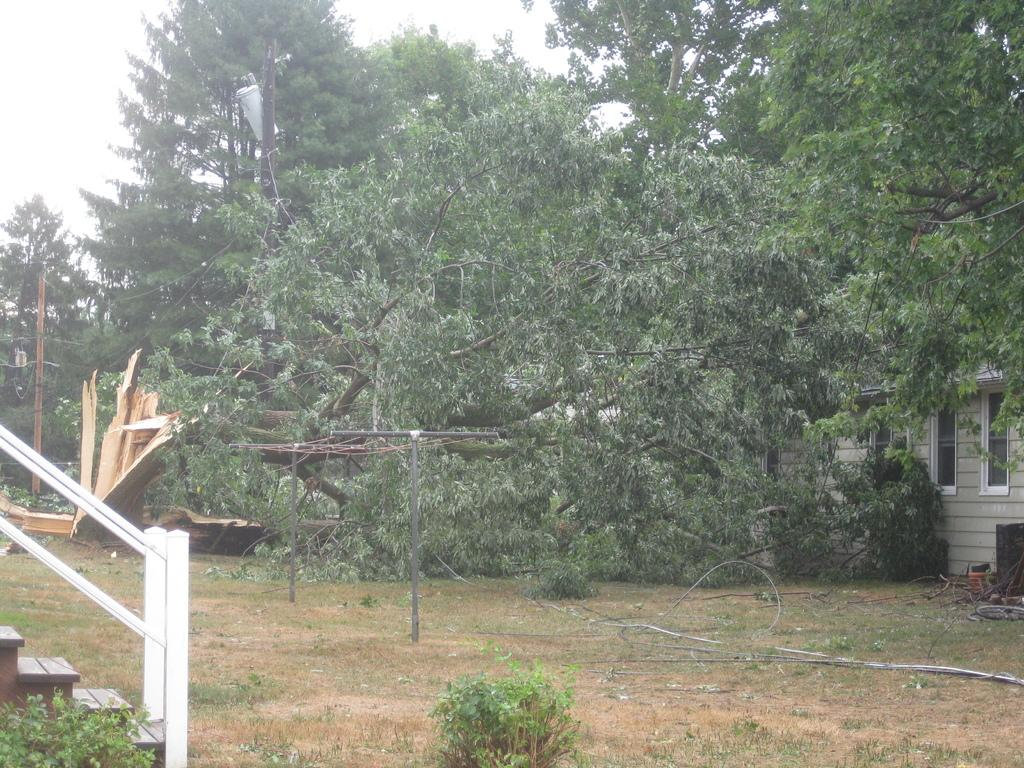What type of terrain is visible in the image? There is a land visible in the image. What architectural feature can be seen in the image? There are stairs in the image. What type of structure is present in the image? There is a house in the image. What type of plant is depicted in the image? There are money trees in the image. Can you tell me how many jewels are on the lawyer in the image? There is no lawyer or jewels present in the image. What type of natural disaster is happening in the image? There is no natural disaster, such as an earthquake, depicted in the image. 